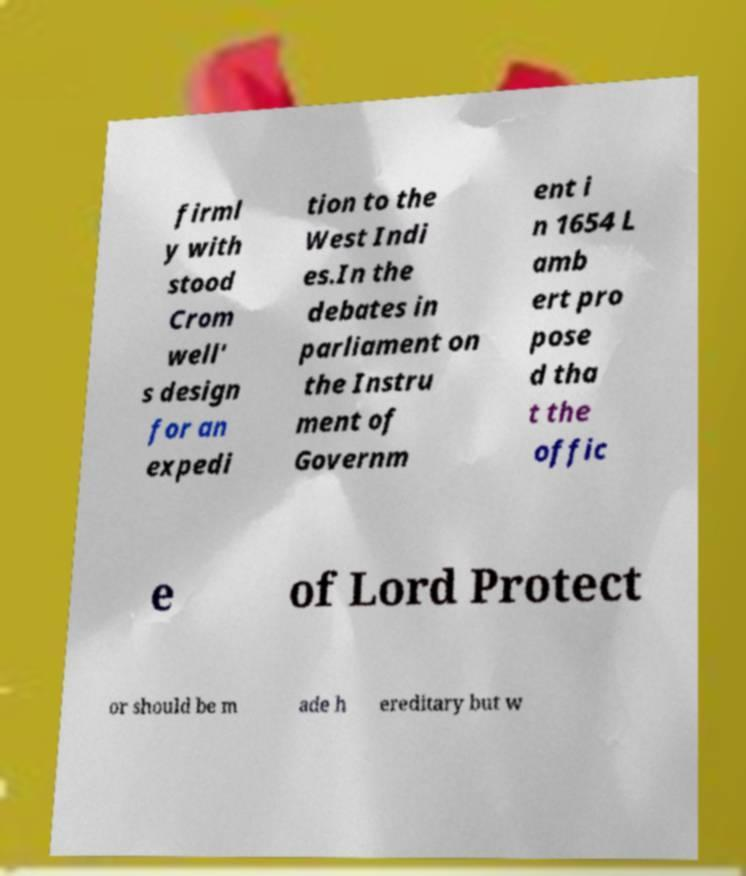Please identify and transcribe the text found in this image. firml y with stood Crom well' s design for an expedi tion to the West Indi es.In the debates in parliament on the Instru ment of Governm ent i n 1654 L amb ert pro pose d tha t the offic e of Lord Protect or should be m ade h ereditary but w 